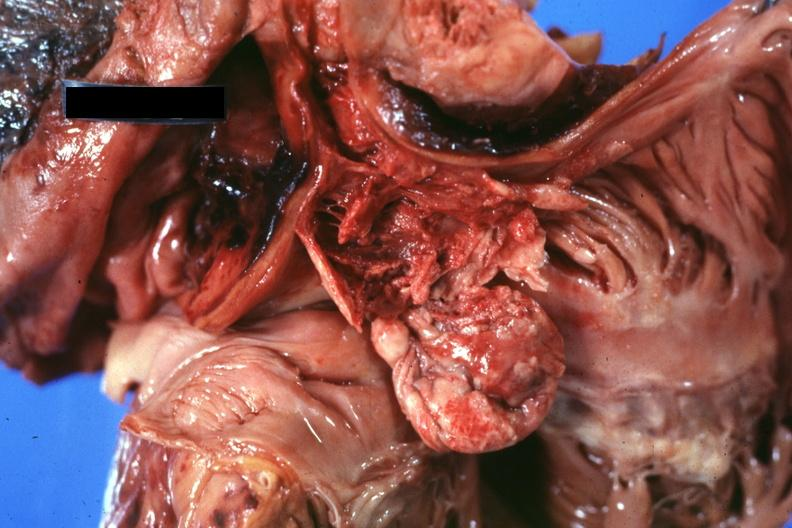where is this part in?
Answer the question using a single word or phrase. Thymus 